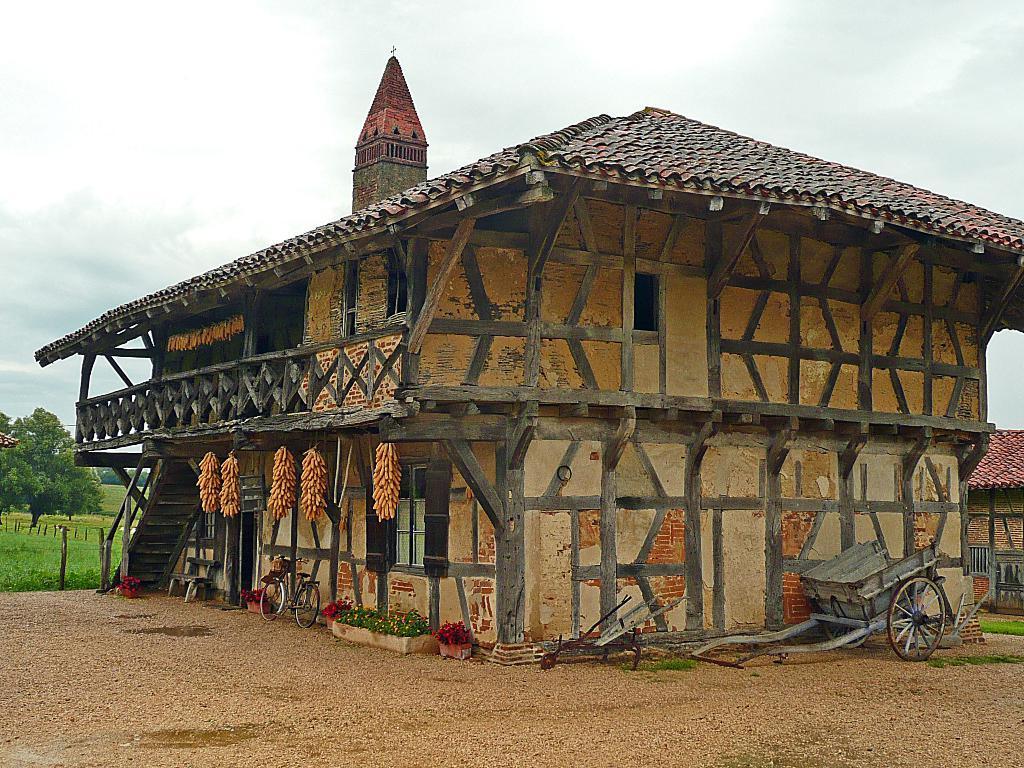Can you describe this image briefly? In this image I can see the ground, a cart which is grey in color, a bicycle, few plants which are green in color and few flowers which are pink in color. I can see a building which is cream and black in color and few stairs of the building. In the background I can see another building, few trees and the sky. 